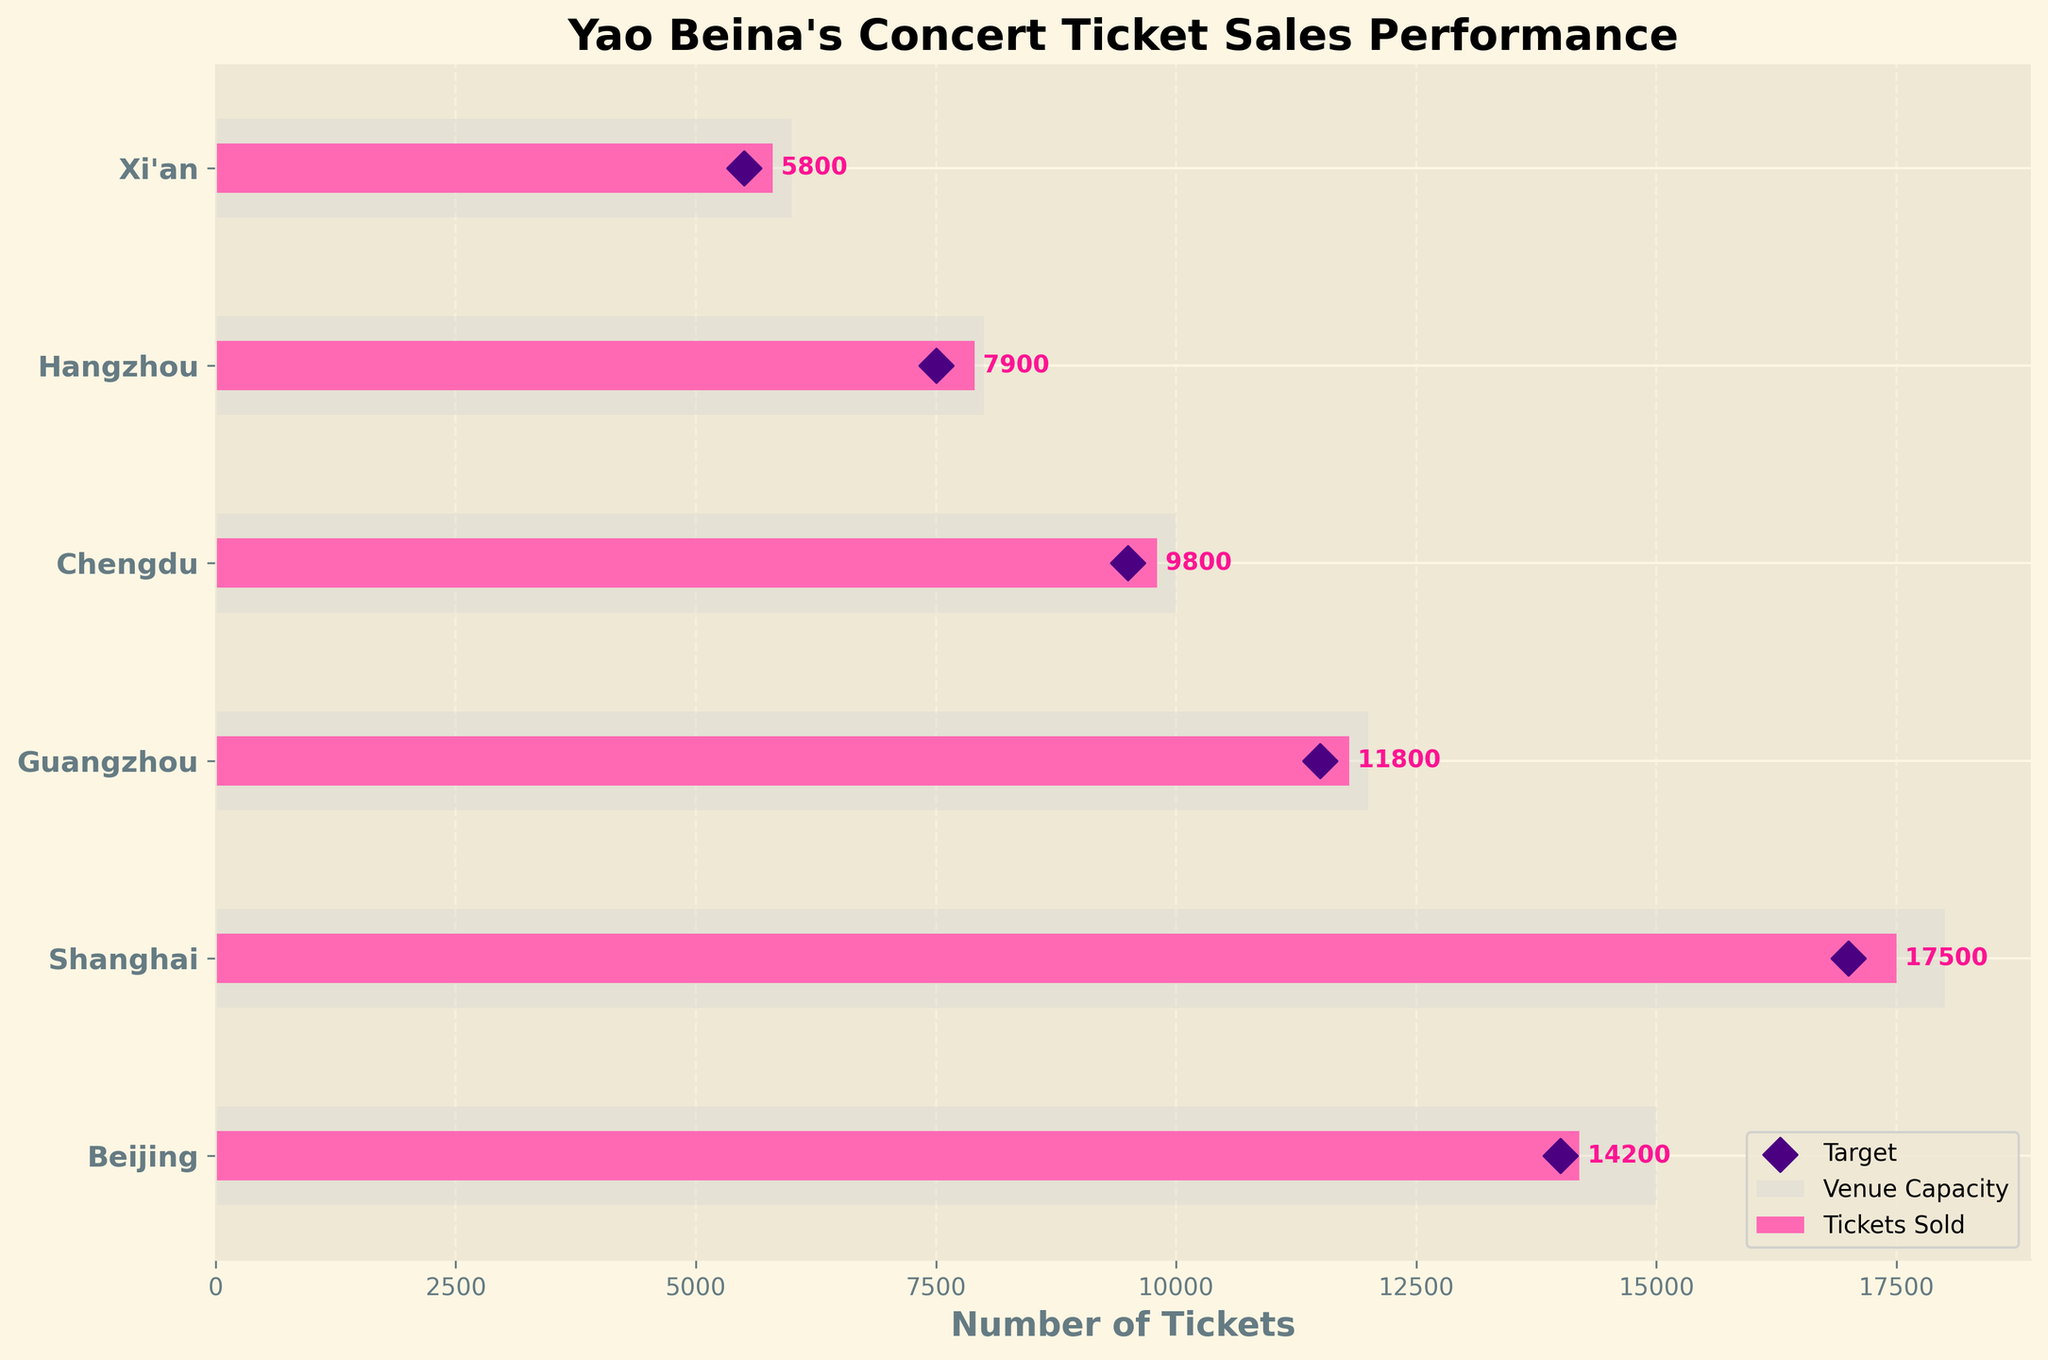Which city had the highest venue capacity? We look at the grey bars in the Bullet Chart to find the highest venue capacity. The bar for Shanghai is the longest.
Answer: Shanghai How many tickets were sold in Beijing? We identify the bar representing ticket sales for Beijing using the pink color and read the value labeled next to it.
Answer: 14200 Is the goal for ticket sales in Chengdu met? Compare the number of tickets sold (pink bar) with the target, which is represented by a purple diamond. Both are at 9500 tickets, indicating the goal was met.
Answer: Yes Which city had the largest difference between the number of tickets sold and the venue capacity? Calculate the difference for each city by subtracting the tickets sold from the venue capacity. Beijing has the largest difference (15000 - 14200 = 800).
Answer: Beijing What's the average number of tickets sold across all cities? Sum the tickets sold and divide by the number of cities: (14200 + 17500 + 11800 + 9800 + 7900 + 5800) / 6.
Answer: 11167 tickets Which city came closest to reaching its target ticket sales? Identify the city where the pink bar (tickets sold) is closest to the purple diamond (target). Beijing exceeded its target by 200 tickets, the smallest difference.
Answer: Beijing What is the total venue capacity across all cities? Sum the venue capacities of all cities: 15000 + 18000 + 12000 + 10000 + 8000 + 6000.
Answer: 69000 Compare the ticket sales in Shanghai and Guangzhou. Which city sold more tickets, and by how much? Shanghai sold 17500 tickets and Guangzhou sold 11800 tickets. The difference is 17500 - 11800.
Answer: Shanghai by 5700 tickets Did Hangzhou meet its target ticket sales? Compare the tickets sold in Hangzhou (7900) with the target (7500). Since 7900 > 7500, Hangzhou met its target.
Answer: Yes What proportion of the tickets were sold in Xi'an compared to its venue capacity? The proportion is calculated by dividing the tickets sold by the venue capacity for Xi'an: 5800 / 6000.
Answer: 0.967 